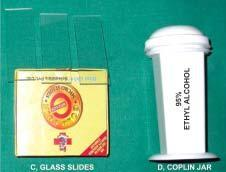what is required for transcutaneous fnac?
Answer the question using a single word or phrase. Equipments 